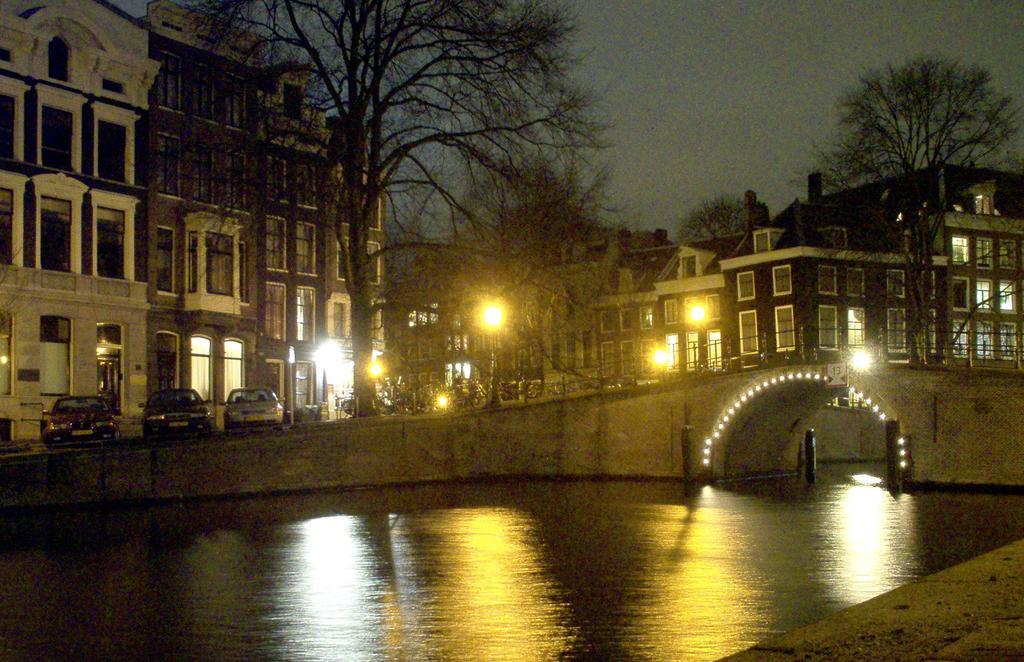Please provide a concise description of this image. At the bottom of the picture, we see water and this water might be in the canal. In the middle of the picture, we see an arch bridge which is decorated with the lights. On the left side, we see the buildings and the cars parked on the road. There are trees, street lights and buildings in the background. At the top, we see the sky. 